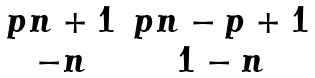Convert formula to latex. <formula><loc_0><loc_0><loc_500><loc_500>\begin{matrix} p n + 1 & p n - p + 1 \\ - n & 1 - n \end{matrix}</formula> 